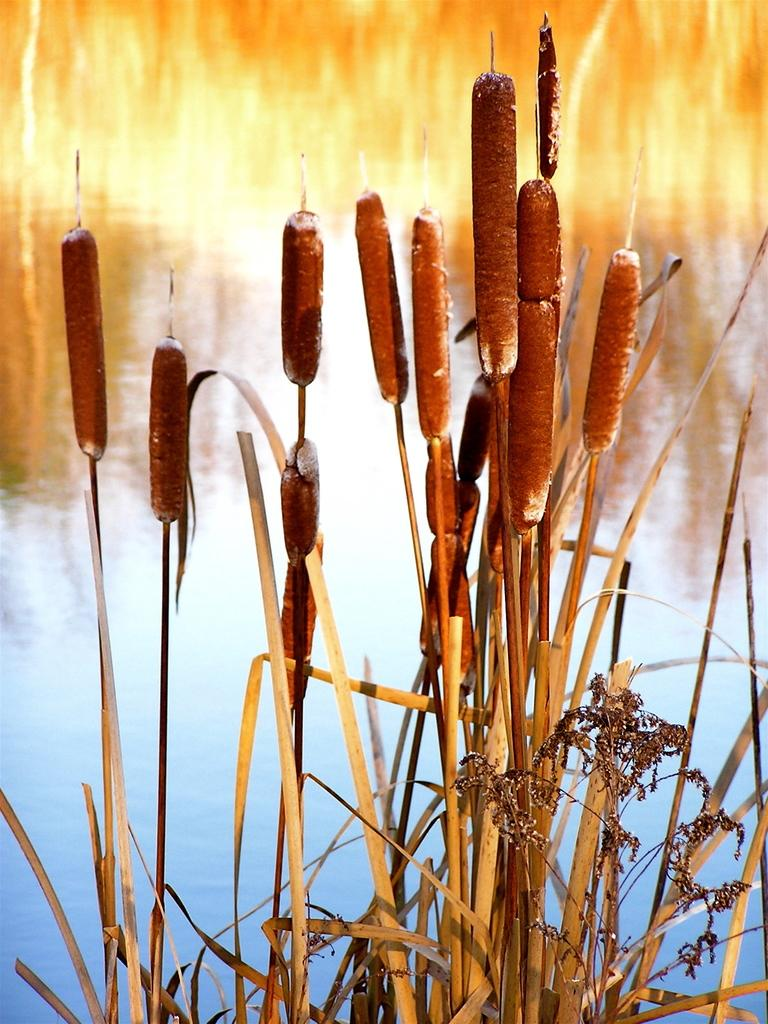What type of surface is visible in the image? There is a lawn in the image. What objects can be seen on the lawn? There are straws visible in the image. What can be seen in the background of the image? There is water visible in the background of the image. What is the tax rate for the straws in the image? There is no information about tax rates in the image, as it only features a lawn and straws. 